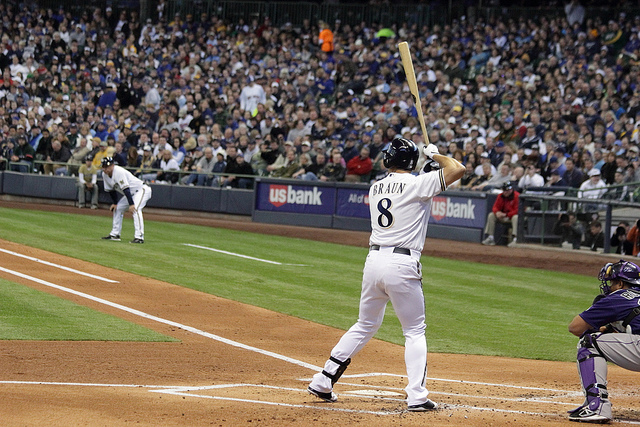How many people can be seen? 4 